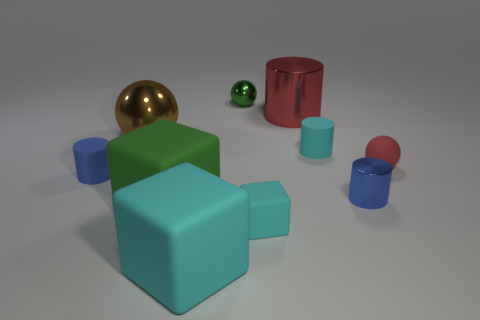What shapes can you identify in the scene? Within this scene, you can identify several geometric shapes: there are spheres, cylinders, and cubes varying in size and color, creating a composition of simple three-dimensional forms. Could you explain why these shapes might be arranged in this way? The arrangement of these shapes could be a deliberate choice by the creator to illustrate concepts such as balance, contrast, and the relationships between different geometric forms within a three-dimensional space. 